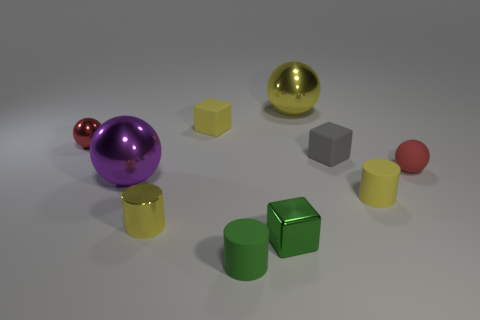Subtract all balls. How many objects are left? 6 Subtract all red rubber objects. Subtract all brown blocks. How many objects are left? 9 Add 4 large things. How many large things are left? 6 Add 5 small gray cubes. How many small gray cubes exist? 6 Subtract 0 red cubes. How many objects are left? 10 